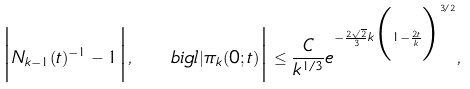Convert formula to latex. <formula><loc_0><loc_0><loc_500><loc_500>\Big | N _ { k - 1 } ( t ) ^ { - 1 } - 1 \Big | , \quad b i g l | \pi _ { k } ( 0 ; t ) \Big | \leq \frac { C } { k ^ { 1 / 3 } } e ^ { - \frac { 2 \sqrt { 2 } } { 3 } k \Big ( 1 - \frac { 2 t } { k } \Big ) ^ { 3 / 2 } } ,</formula> 